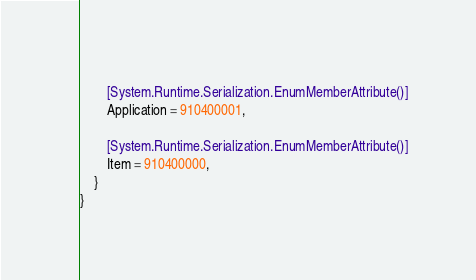<code> <loc_0><loc_0><loc_500><loc_500><_C#_>		
		[System.Runtime.Serialization.EnumMemberAttribute()]
		Application = 910400001,
		
		[System.Runtime.Serialization.EnumMemberAttribute()]
		Item = 910400000,
	}
}</code> 